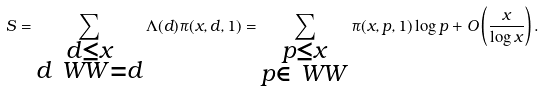<formula> <loc_0><loc_0><loc_500><loc_500>S = \sum _ { \substack { d \leq x \\ d _ { \ } W W = d } } \Lambda ( d ) \pi ( x , d , 1 ) = \sum _ { \substack { p \leq x \\ p \in \ W W } } \pi ( x , p , 1 ) \log p + O \left ( \frac { x } { \log x } \right ) .</formula> 